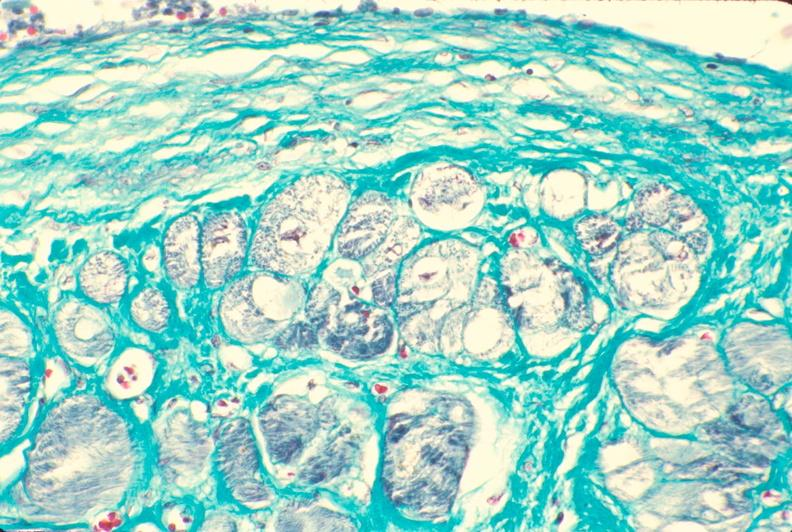does this image show heart, subendocardial vacuolation, chronic ischemic heart disease?
Answer the question using a single word or phrase. Yes 